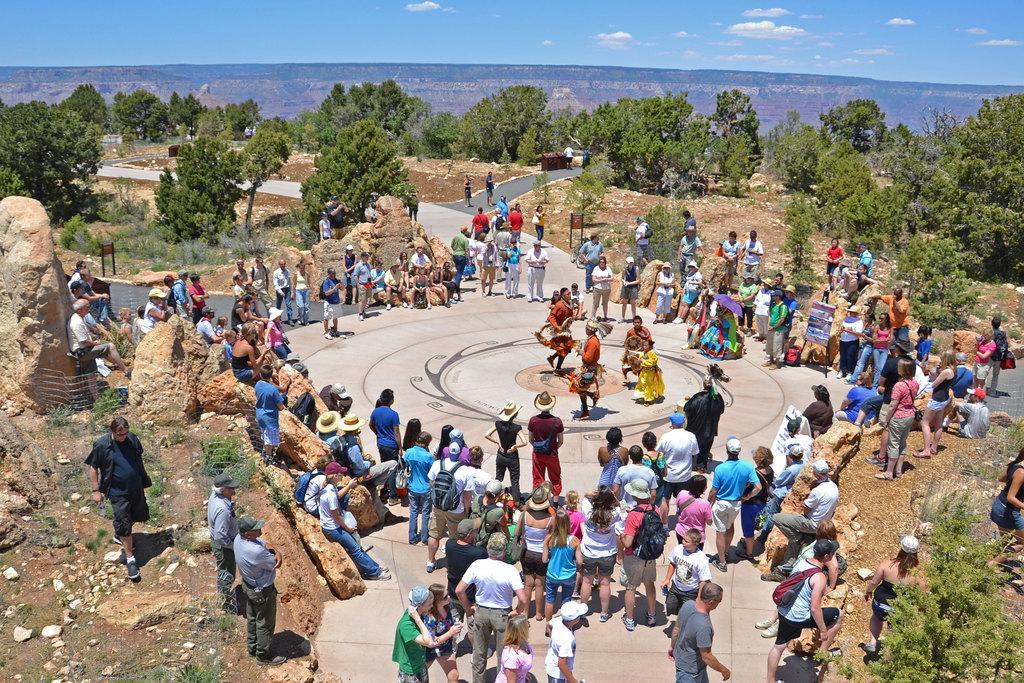Describe this image in one or two sentences. In this picture there are four members dancing on the floor here. There are some people watching them. Some of them were sitting and some of them were standing. There were men and women in this group. We can observe stones in this picture. In the background there are trees, hills and a sky with clouds. 